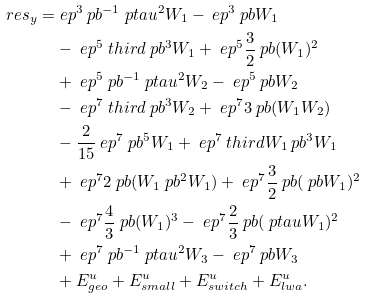<formula> <loc_0><loc_0><loc_500><loc_500>\ r e s _ { y } = & \ e p ^ { 3 } \ p b ^ { - 1 } \ p t a u ^ { 2 } W _ { 1 } - \ e p ^ { 3 } \ p b W _ { 1 } \\ & - \ e p ^ { 5 } \ t h i r d \ p b ^ { 3 } W _ { 1 } + \ e p ^ { 5 } \frac { 3 } { 2 } \ p b ( W _ { 1 } ) ^ { 2 } \\ & + \ e p ^ { 5 } \ p b ^ { - 1 } \ p t a u ^ { 2 } W _ { 2 } - \ e p ^ { 5 } \ p b W _ { 2 } \\ & - \ e p ^ { 7 } \ t h i r d \ p b ^ { 3 } W _ { 2 } + \ e p ^ { 7 } 3 \ p b ( W _ { 1 } W _ { 2 } ) \\ & - \frac { 2 } { 1 5 } \ e p ^ { 7 } \ p b ^ { 5 } W _ { 1 } + \ e p ^ { 7 } \ t h i r d W _ { 1 } \ p b ^ { 3 } W _ { 1 } \\ & + \ e p ^ { 7 } 2 \ p b ( W _ { 1 } \ p b ^ { 2 } W _ { 1 } ) + \ e p ^ { 7 } \frac { 3 } { 2 } \ p b ( \ p b W _ { 1 } ) ^ { 2 } \\ & - \ e p ^ { 7 } \frac { 4 } { 3 } \ p b ( W _ { 1 } ) ^ { 3 } - \ e p ^ { 7 } \frac { 2 } { 3 } \ p b ( \ p t a u W _ { 1 } ) ^ { 2 } \\ & + \ e p ^ { 7 } \ p b ^ { - 1 } \ p t a u ^ { 2 } W _ { 3 } - \ e p ^ { 7 } \ p b W _ { 3 } \\ & + E ^ { u } _ { g e o } + E ^ { u } _ { s m a l l } + E ^ { u } _ { s w i t c h } + E ^ { u } _ { l w a } .</formula> 